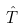Convert formula to latex. <formula><loc_0><loc_0><loc_500><loc_500>\hat { T }</formula> 